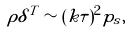<formula> <loc_0><loc_0><loc_500><loc_500>\rho \delta ^ { T } \sim ( k \tau ) ^ { 2 } p _ { s } ,</formula> 